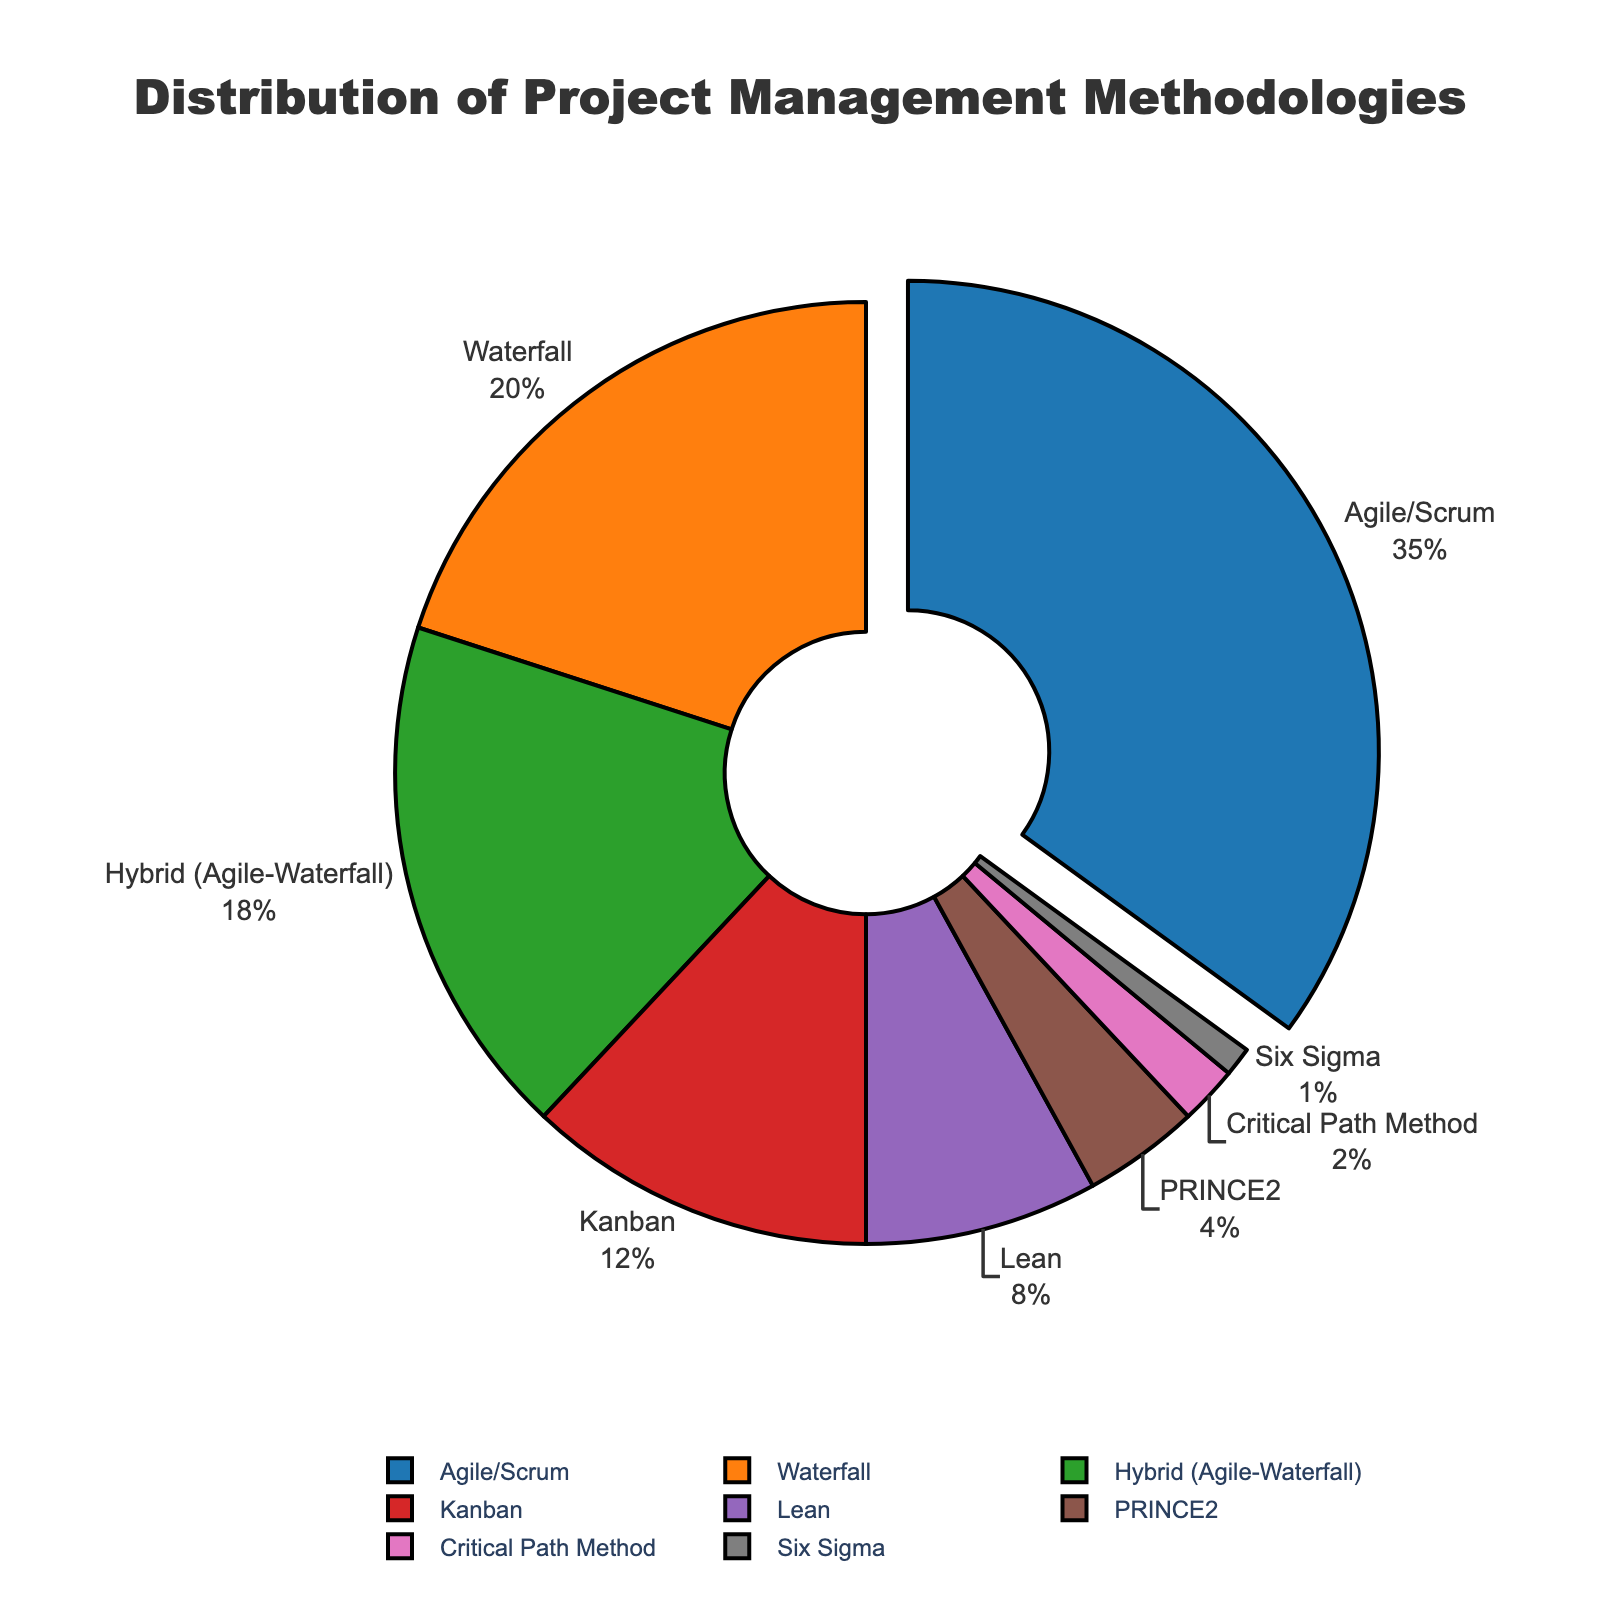What's the most popular project management methodology? The pie chart shows various methodologies and their percentages. The highest percentage is pulled out, representing Agile/Scrum with 35%.
Answer: Agile/Scrum What's the least popular project management methodology? The pie chart shows various methodologies and their percentages. The lowest percentage is associated with Six Sigma at 1%.
Answer: Six Sigma What is the total percentage of traditional management approaches (Waterfall + PRINCE2 + Critical Path Method)? Add the percentages of Waterfall (20%), PRINCE2 (4%), and Critical Path Method (2%): 20% + 4% + 2% = 26%.
Answer: 26% Which management methodologies together cover more than half of the distribution? Agile/Scrum (35%) and Waterfall (20%) together make 55%, which is more than half.
Answer: Agile/Scrum and Waterfall How much more popular is Agile/Scrum compared to Kanban? Subtract the percentage of Kanban (12%) from Agile/Scrum (35%): 35% - 12% = 23%.
Answer: 23% How many methodologies have a percentage greater than 10%? The pie chart shows Agile/Scrum (35%), Waterfall (20%), Hybrid (18%), and Kanban (12%) as having percentages greater than 10%.
Answer: 4 What's the cumulative percentage of Agile/Scrum, Waterfall, and Hybrid combined? Add the percentages of Agile/Scrum (35%), Waterfall (20%), and Hybrid (18%): 35% + 20% + 18% = 73%.
Answer: 73% Which management methodology has a percentage that is twice that of Lean? The percentage of Lean is 8%. The closest percentage that is twice Lean’s value is Kanban at 12%.
Answer: None By how much does the percentage of Hybrid exceed PRINCE2? Subtract the percentage of PRINCE2 (4%) from Hybrid (18%): 18% - 4% = 14%.
Answer: 14% What percentage of methodologies other than Agile/Scrum are used in the chart? Subtract Agile/Scrum’s percentage (35%) from 100%: 100% - 35% = 65%.
Answer: 65% 